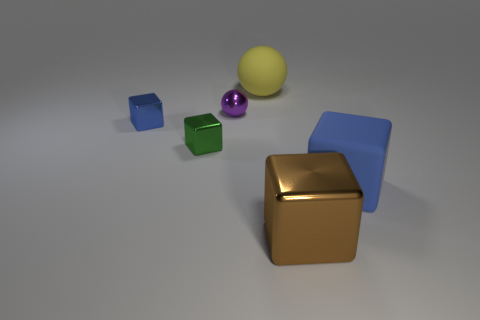Which objects in the image appear to have a reflective surface? The gold cube has a highly reflective metallic surface. The purple and yellow spheres also have shiny surfaces that reflect some of the surrounding light. 